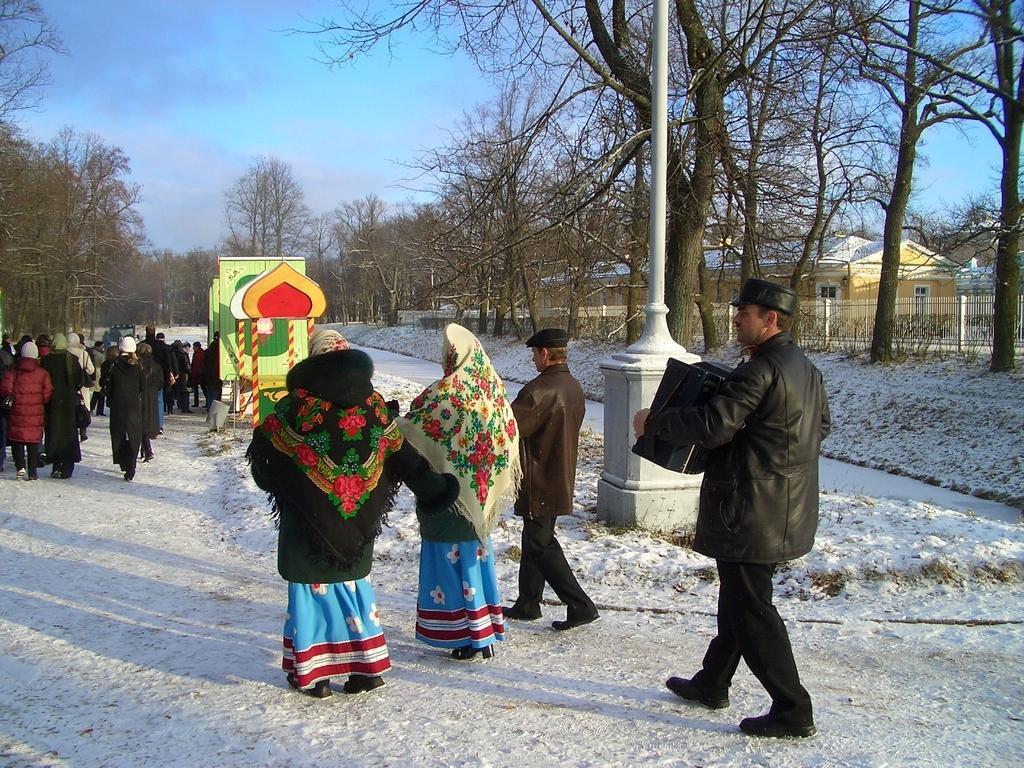Describe this image in one or two sentences. This picture is taken from the outside of the city. In this image, in the middle, we can see three people are walking on the road. On the right side, we can see a man wearing a black color dress and holding an object in his hand is walking on the road. On the left side, we can see a group of people walking on the road. On the left side, we can also see some trees. In the background, we can see a box, pole. In the background, we can also see some trees, houses, glass window, metal grill. At the top, we can see a sky, at the bottom, we can see land and a snow. 